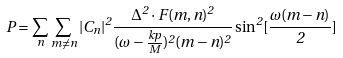<formula> <loc_0><loc_0><loc_500><loc_500>P = \sum _ { n } \sum _ { m \ne n } | C _ { n } | ^ { 2 } \frac { \Delta ^ { 2 } \cdot F ( m , n ) ^ { 2 } } { ( \omega - \frac { k p } { M } ) ^ { 2 } ( m - n ) ^ { 2 } } \sin ^ { 2 } [ \frac { \omega ( m - n ) } { 2 } ]</formula> 